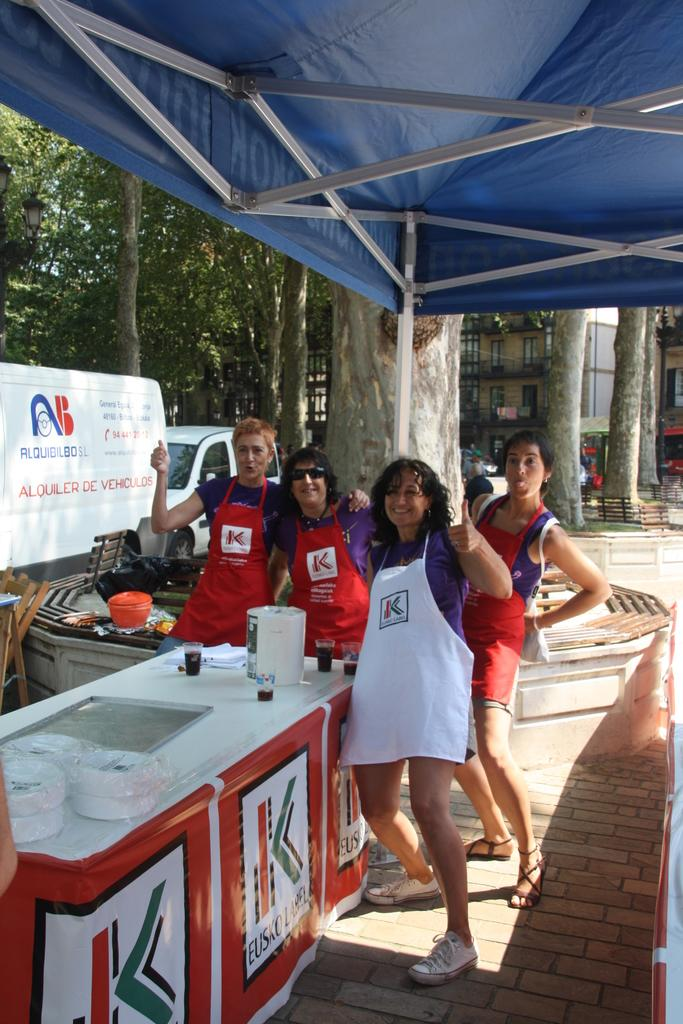<image>
Provide a brief description of the given image. Alquiler De Vehiculos is printed on the sign behind the stand. 